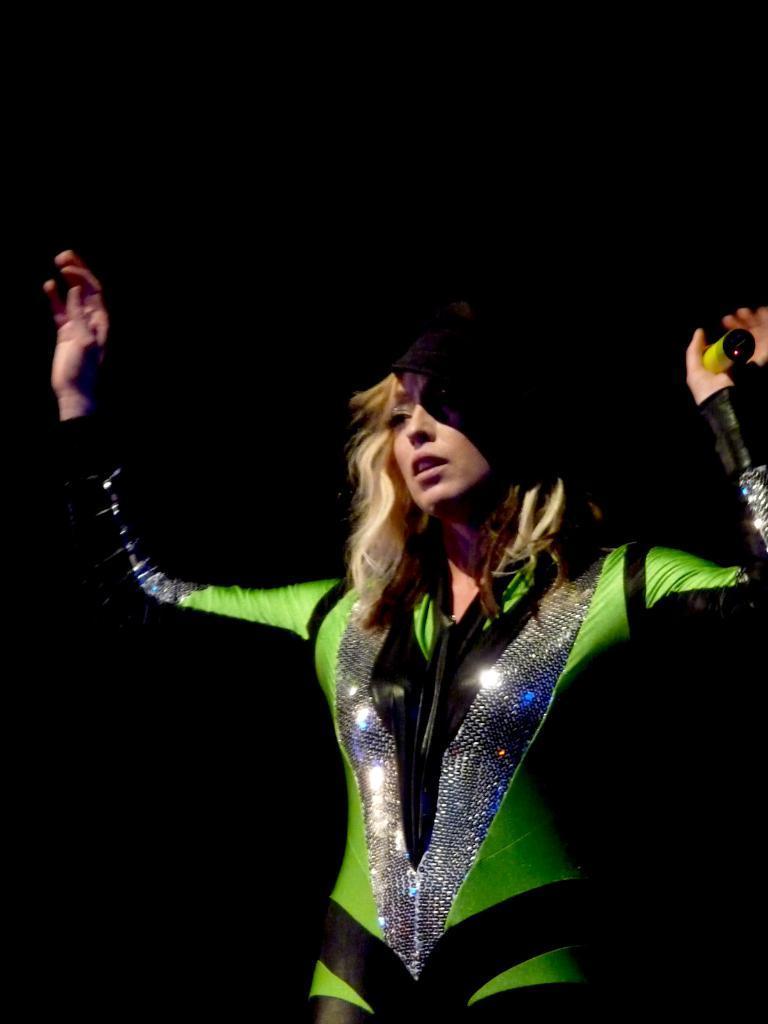Could you give a brief overview of what you see in this image? In this picture we can see a woman wearing a costume and holding an object in her hand. Background is black in color. 